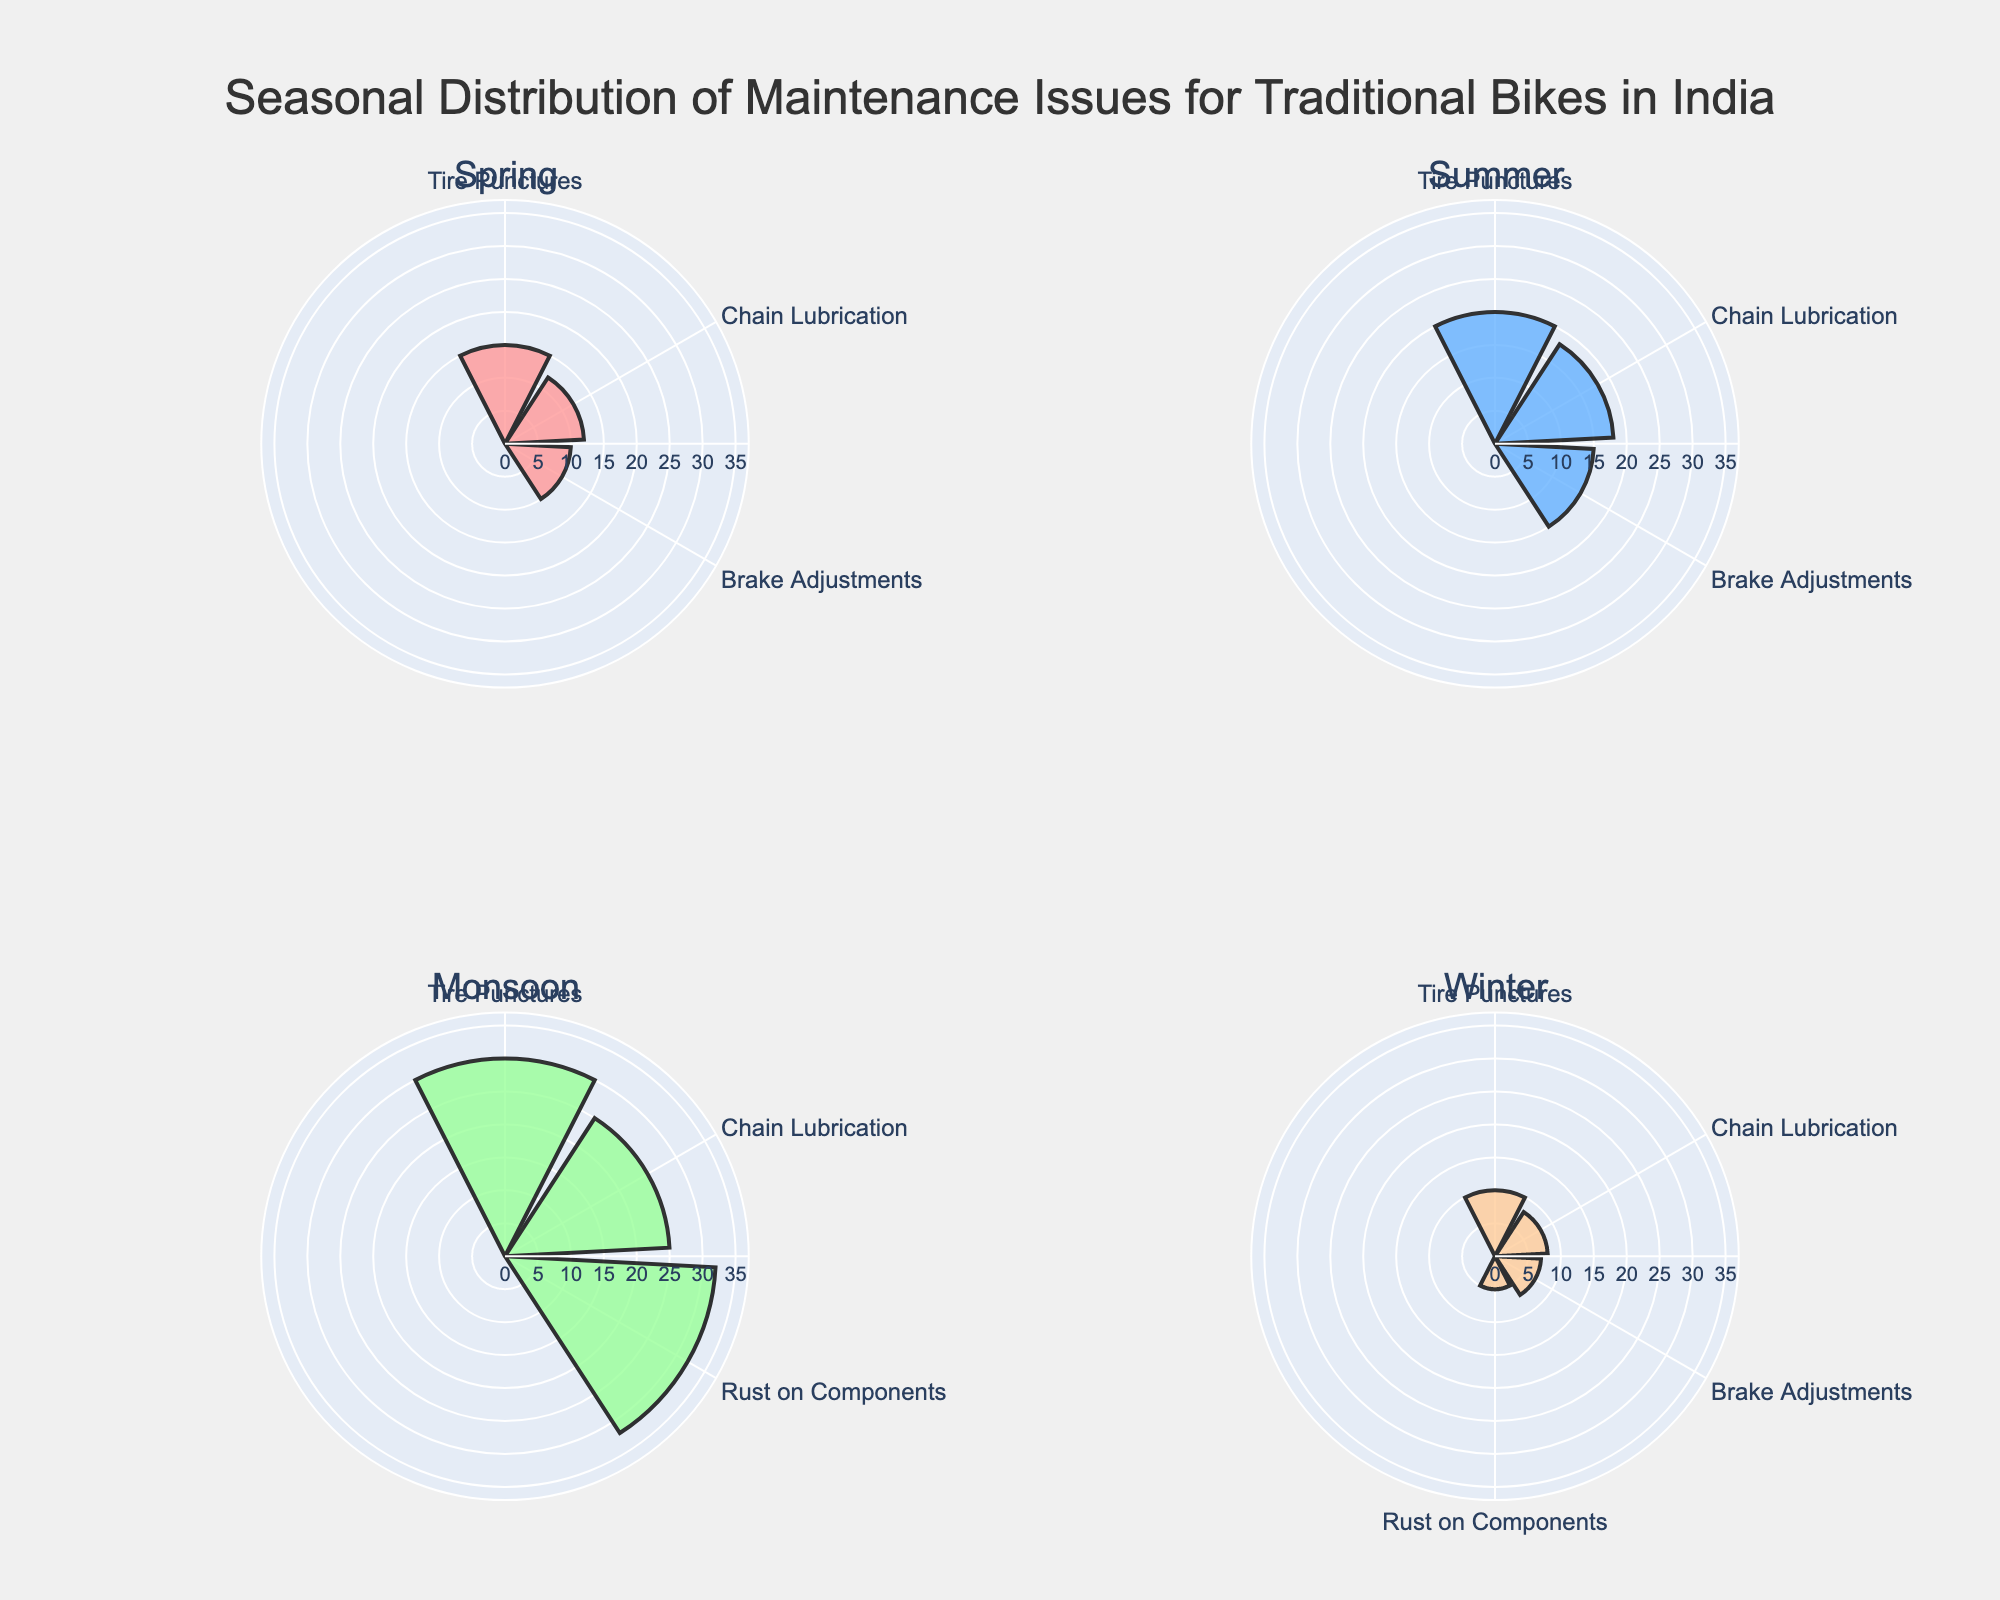What is the title of the figure? The title is given at the top of the figure and usually explains the content or purpose of the chart. Here, it reads as "Seasonal Distribution of Maintenance Issues for Traditional Bikes in India".
Answer: Seasonal Distribution of Maintenance Issues for Traditional Bikes in India Which season has the highest frequency of tire punctures? By looking at the subplot for each season and comparing the lengths of the bars for tire punctures, the longest bar appears in the Monsoon season. This indicates that the frequency is highest in Monsoon.
Answer: Monsoon What is the combined frequency of chain lubrication issues in Spring and Winter? To find the combined frequency, add the frequency of chain lubrication in Spring (12) to the frequency of chain lubrication in Winter (8). So, the combined frequency is 12 + 8 = 20.
Answer: 20 Which maintenance issue appears only in two seasons? Looking at each subplot, 'Rust on Components' appears only in the Monsoon and Winter seasons, as indicated by the corresponding bar in these subplots.
Answer: Rust on Components How does the frequency of brake adjustments in Summer compare to that in Winter? By comparing the bar lengths for brake adjustments in Summer and Winter, Summer has a bar length of 15 and Winter has a bar length of 7. So, brake adjustments are more frequent in Summer compared to Winter.
Answer: More in Summer Which season has the least variety of maintenance issues? The number of distinct maintenance issues in each season can be counted by looking at the labels in each subplot. Winter has four different issues (Tire Punctures, Chain Lubrication, Brake Adjustments, Rust on Components), while all other seasons have fewer.
Answer: Winter What is the frequency difference of tire punctures between Monsoon and Spring? To find the difference, subtract the frequency in Spring (15) from the frequency in Monsoon (30). So, the difference is 30 - 15 = 15.
Answer: 15 In which season is rust on components observed the most? Comparing the subplots where rust on components is present (Monsoon and Winter), the frequency is higher in Monsoon (32) compared to Winter (5).
Answer: Monsoon 